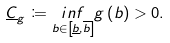Convert formula to latex. <formula><loc_0><loc_0><loc_500><loc_500>\underline { C } _ { g } \coloneqq \underset { b \in \left [ \underline { b } , \overline { b } \right ] } { i n f } g \left ( b \right ) > 0 .</formula> 